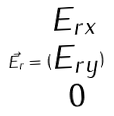Convert formula to latex. <formula><loc_0><loc_0><loc_500><loc_500>\vec { E _ { r } } = ( \begin{matrix} E _ { r x } \\ E _ { r y } \\ 0 \end{matrix} )</formula> 